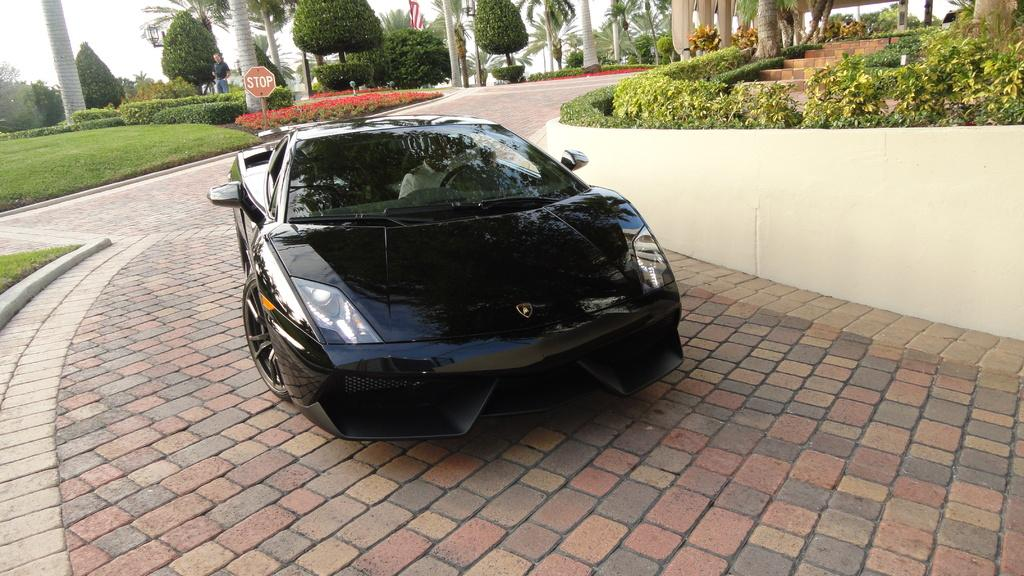What type of vehicle is in the image? There is a black color sports car in the image. What can be seen in the background of the image? There are trees, plants, and a sign board in the image. Can you describe the person in the image? There is a human standing in the image. What is the weather like in the image? The sky is cloudy in the image. What is on the ground in the image? There is grass on the ground in the image. Where is the cemetery located in the image? There is no cemetery present in the image. What type of structure can be seen in the image? There is no specific structure mentioned in the provided facts; the image only contains a sports car, trees, plants, a sign board, a human, a flag, and grass. 